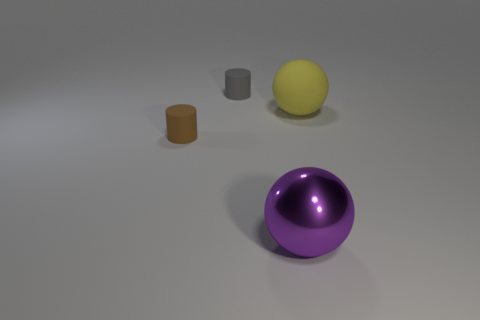Add 3 large yellow things. How many objects exist? 7 Subtract 1 spheres. How many spheres are left? 1 Subtract all cyan spheres. How many brown cylinders are left? 1 Subtract all gray cylinders. How many cylinders are left? 1 Subtract 0 brown spheres. How many objects are left? 4 Subtract all brown balls. Subtract all cyan cylinders. How many balls are left? 2 Subtract all large green metal cylinders. Subtract all large purple metallic things. How many objects are left? 3 Add 2 brown rubber objects. How many brown rubber objects are left? 3 Add 2 purple metal balls. How many purple metal balls exist? 3 